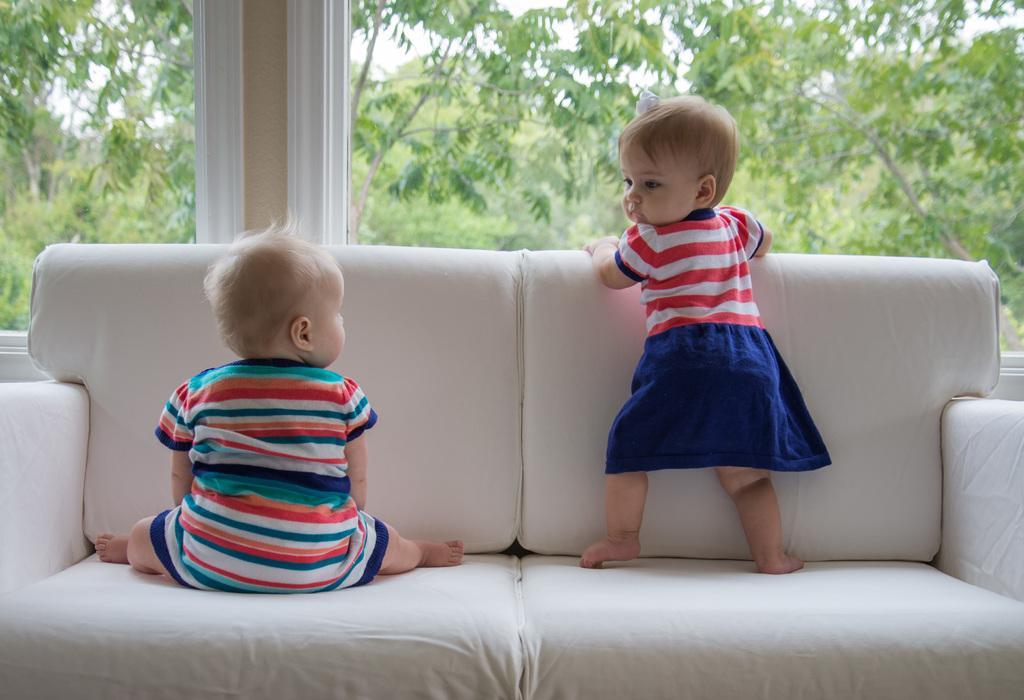How would you summarize this image in a sentence or two? In this image, we can see 2 babies are on the couch. One baby is stand and another baby is sat on the couch. We can see white color couch in the image. At the background, we can see a pillar, some trees. The right side baby on his head, we can see a white color clip and blue color on her dress. 